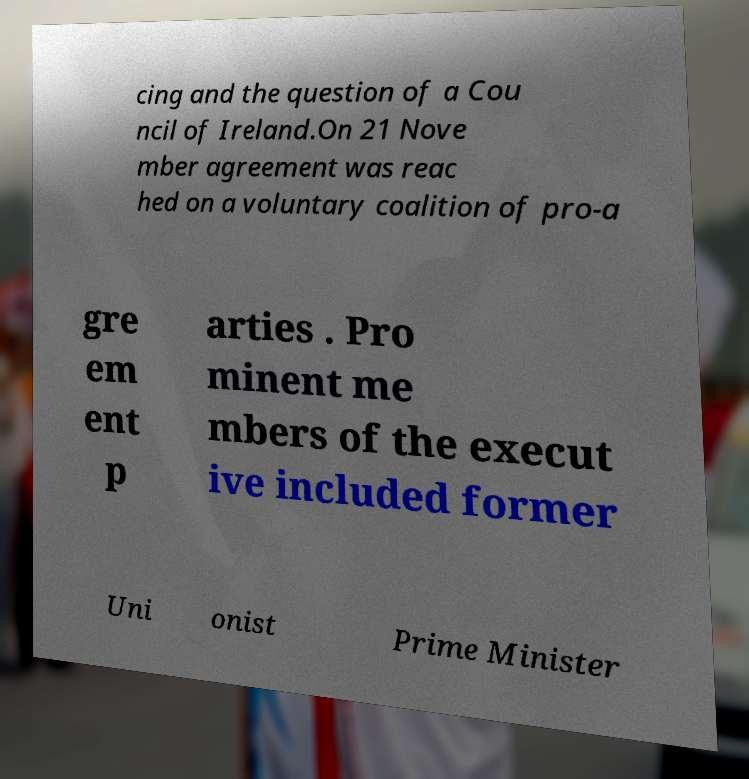Can you read and provide the text displayed in the image?This photo seems to have some interesting text. Can you extract and type it out for me? cing and the question of a Cou ncil of Ireland.On 21 Nove mber agreement was reac hed on a voluntary coalition of pro-a gre em ent p arties . Pro minent me mbers of the execut ive included former Uni onist Prime Minister 